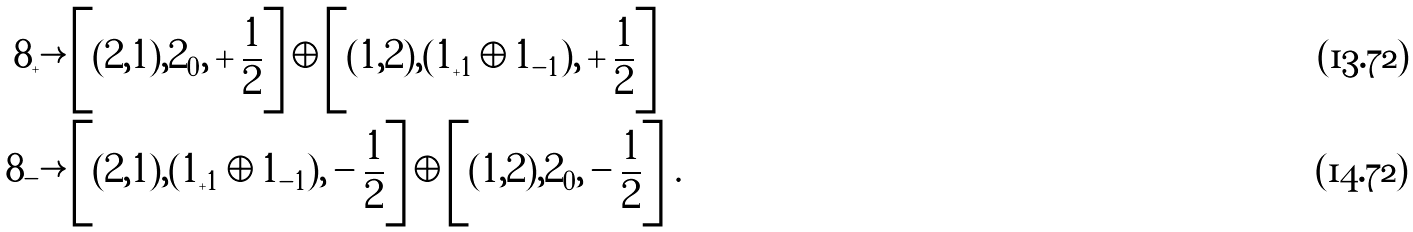Convert formula to latex. <formula><loc_0><loc_0><loc_500><loc_500>8 _ { + } & \rightarrow \left [ ( 2 , 1 ) , 2 _ { 0 } , + \frac { 1 } { 2 } \right ] \oplus \left [ ( 1 , 2 ) , ( 1 _ { + 1 } \oplus 1 _ { - 1 } ) , + \frac { 1 } { 2 } \right ] \\ 8 _ { - } & \rightarrow \left [ ( 2 , 1 ) , ( 1 _ { + 1 } \oplus 1 _ { - 1 } ) , - \frac { 1 } { 2 } \right ] \oplus \left [ ( 1 , 2 ) , 2 _ { 0 } , - \frac { 1 } { 2 } \right ] \, .</formula> 